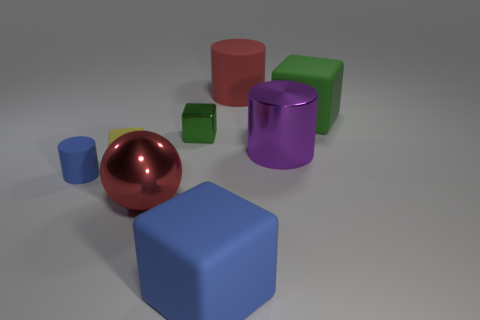Add 1 yellow matte objects. How many objects exist? 9 Subtract all brown cubes. Subtract all gray spheres. How many cubes are left? 4 Subtract all cylinders. How many objects are left? 5 Subtract 1 red spheres. How many objects are left? 7 Subtract all small brown balls. Subtract all tiny green objects. How many objects are left? 7 Add 2 tiny metal objects. How many tiny metal objects are left? 3 Add 1 tiny rubber cylinders. How many tiny rubber cylinders exist? 2 